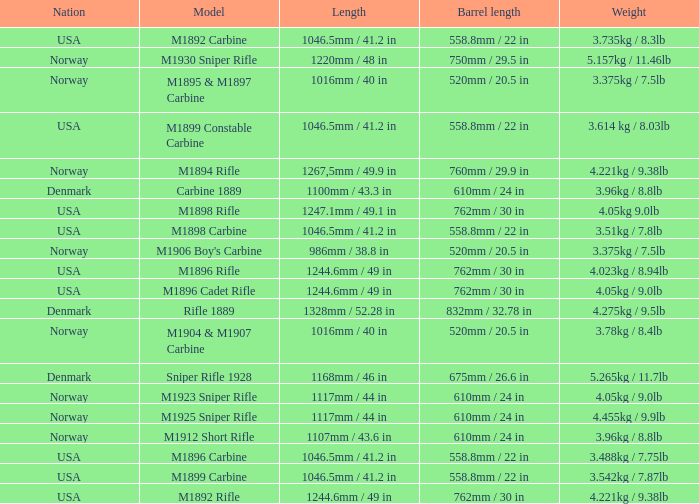What is Nation, when Model is M1895 & M1897 Carbine? Norway. Give me the full table as a dictionary. {'header': ['Nation', 'Model', 'Length', 'Barrel length', 'Weight'], 'rows': [['USA', 'M1892 Carbine', '1046.5mm / 41.2 in', '558.8mm / 22 in', '3.735kg / 8.3lb'], ['Norway', 'M1930 Sniper Rifle', '1220mm / 48 in', '750mm / 29.5 in', '5.157kg / 11.46lb'], ['Norway', 'M1895 & M1897 Carbine', '1016mm / 40 in', '520mm / 20.5 in', '3.375kg / 7.5lb'], ['USA', 'M1899 Constable Carbine', '1046.5mm / 41.2 in', '558.8mm / 22 in', '3.614 kg / 8.03lb'], ['Norway', 'M1894 Rifle', '1267,5mm / 49.9 in', '760mm / 29.9 in', '4.221kg / 9.38lb'], ['Denmark', 'Carbine 1889', '1100mm / 43.3 in', '610mm / 24 in', '3.96kg / 8.8lb'], ['USA', 'M1898 Rifle', '1247.1mm / 49.1 in', '762mm / 30 in', '4.05kg 9.0lb'], ['USA', 'M1898 Carbine', '1046.5mm / 41.2 in', '558.8mm / 22 in', '3.51kg / 7.8lb'], ['Norway', "M1906 Boy's Carbine", '986mm / 38.8 in', '520mm / 20.5 in', '3.375kg / 7.5lb'], ['USA', 'M1896 Rifle', '1244.6mm / 49 in', '762mm / 30 in', '4.023kg / 8.94lb'], ['USA', 'M1896 Cadet Rifle', '1244.6mm / 49 in', '762mm / 30 in', '4.05kg / 9.0lb'], ['Denmark', 'Rifle 1889', '1328mm / 52.28 in', '832mm / 32.78 in', '4.275kg / 9.5lb'], ['Norway', 'M1904 & M1907 Carbine', '1016mm / 40 in', '520mm / 20.5 in', '3.78kg / 8.4lb'], ['Denmark', 'Sniper Rifle 1928', '1168mm / 46 in', '675mm / 26.6 in', '5.265kg / 11.7lb'], ['Norway', 'M1923 Sniper Rifle', '1117mm / 44 in', '610mm / 24 in', '4.05kg / 9.0lb'], ['Norway', 'M1925 Sniper Rifle', '1117mm / 44 in', '610mm / 24 in', '4.455kg / 9.9lb'], ['Norway', 'M1912 Short Rifle', '1107mm / 43.6 in', '610mm / 24 in', '3.96kg / 8.8lb'], ['USA', 'M1896 Carbine', '1046.5mm / 41.2 in', '558.8mm / 22 in', '3.488kg / 7.75lb'], ['USA', 'M1899 Carbine', '1046.5mm / 41.2 in', '558.8mm / 22 in', '3.542kg / 7.87lb'], ['USA', 'M1892 Rifle', '1244.6mm / 49 in', '762mm / 30 in', '4.221kg / 9.38lb']]} 